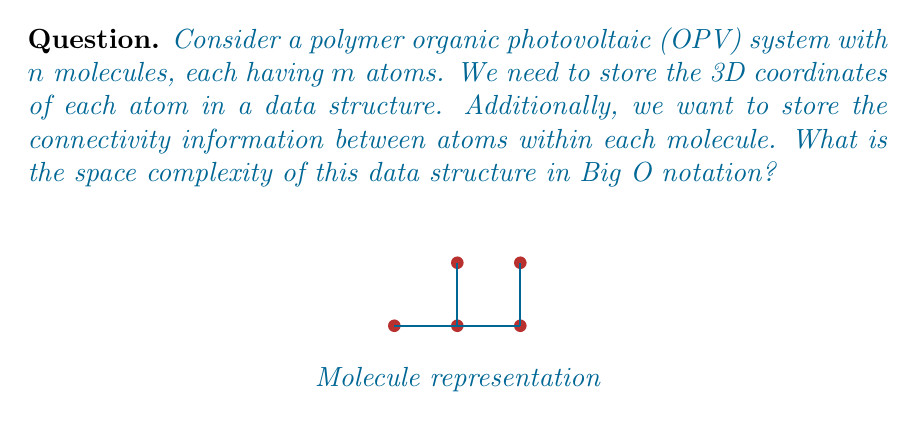Can you answer this question? Let's break down the space complexity analysis step by step:

1. Storing atom coordinates:
   - Each atom has 3 coordinates (x, y, z)
   - There are $m$ atoms per molecule
   - There are $n$ molecules
   - Space required: $O(3mn)$ = $O(mn)$

2. Storing connectivity information:
   - In the worst case, each atom can be connected to every other atom in the molecule
   - Maximum number of connections per molecule: $\binom{m}{2} = \frac{m(m-1)}{2}$
   - There are $n$ molecules
   - Space required: $O(n \cdot \frac{m(m-1)}{2})$ = $O(nm^2)$

3. Total space complexity:
   - Sum of space for coordinates and connectivity
   - $O(mn) + O(nm^2)$ = $O(nm^2)$

The dominant term is $O(nm^2)$, which represents the worst-case scenario for storing connectivity information.

For a materials scientist skeptical about OPVs, this analysis shows that the space complexity grows quadratically with the number of atoms per molecule. This could be a concern for storing and processing data for large, complex polymer systems, potentially limiting the practicality of simulating or analyzing very large OPV structures.
Answer: $O(nm^2)$ 